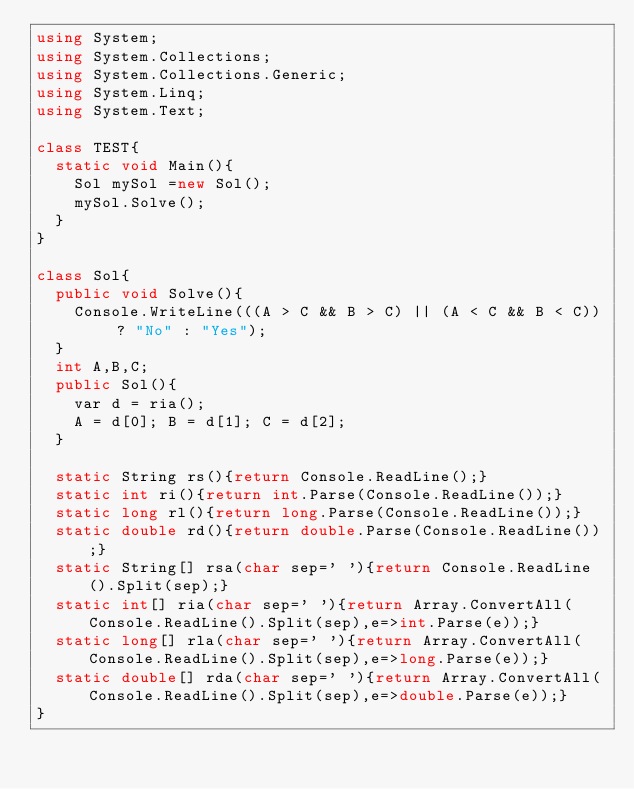<code> <loc_0><loc_0><loc_500><loc_500><_C#_>using System;
using System.Collections;
using System.Collections.Generic;
using System.Linq;
using System.Text;

class TEST{
	static void Main(){
		Sol mySol =new Sol();
		mySol.Solve();
	}
}

class Sol{
	public void Solve(){
		Console.WriteLine(((A > C && B > C) || (A < C && B < C)) ? "No" : "Yes");
	}
	int A,B,C;
	public Sol(){
		var d = ria();
		A = d[0]; B = d[1]; C = d[2];
	}

	static String rs(){return Console.ReadLine();}
	static int ri(){return int.Parse(Console.ReadLine());}
	static long rl(){return long.Parse(Console.ReadLine());}
	static double rd(){return double.Parse(Console.ReadLine());}
	static String[] rsa(char sep=' '){return Console.ReadLine().Split(sep);}
	static int[] ria(char sep=' '){return Array.ConvertAll(Console.ReadLine().Split(sep),e=>int.Parse(e));}
	static long[] rla(char sep=' '){return Array.ConvertAll(Console.ReadLine().Split(sep),e=>long.Parse(e));}
	static double[] rda(char sep=' '){return Array.ConvertAll(Console.ReadLine().Split(sep),e=>double.Parse(e));}
}
</code> 